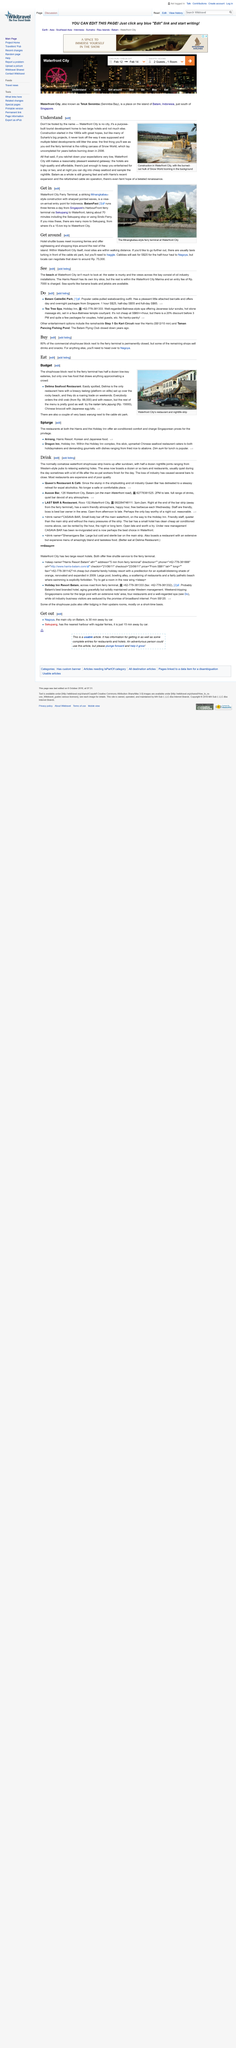List a handful of essential elements in this visual. Waterfront City is a purpose-built tourist development that consists of two large hotels, designed to cater to the needs of visitors seeking a unique and memorable vacation experience. It is located in the heart of Dubai, near the famous Dubai Creek, and is surrounded by a variety of shops, restaurants, and entertainment venues. The development is designed to provide guests with a range of amenities, including luxurious accommodations, first-class dining options, and access to a wide range of recreational activities. With its stunning architecture, beautiful waterfront location, and exceptional amenities, Waterfront City is a premier destination for tourists visiting Dubai. There are high-quality and affordable hotels available in Waterfront City that offer a comfortable and convenient stay for visitors. The Waterfront City Terminal utilized the construction style of Minangkabau, a traditional Malay architecture known for its intricate woodwork and lattice-like patterns. The above image was captured at Waterfront City's restaurant and nightlife strip, which is located in the city of Dubai. The going rate for a half-hour cab ride to Nagoya is approximately S$20. 